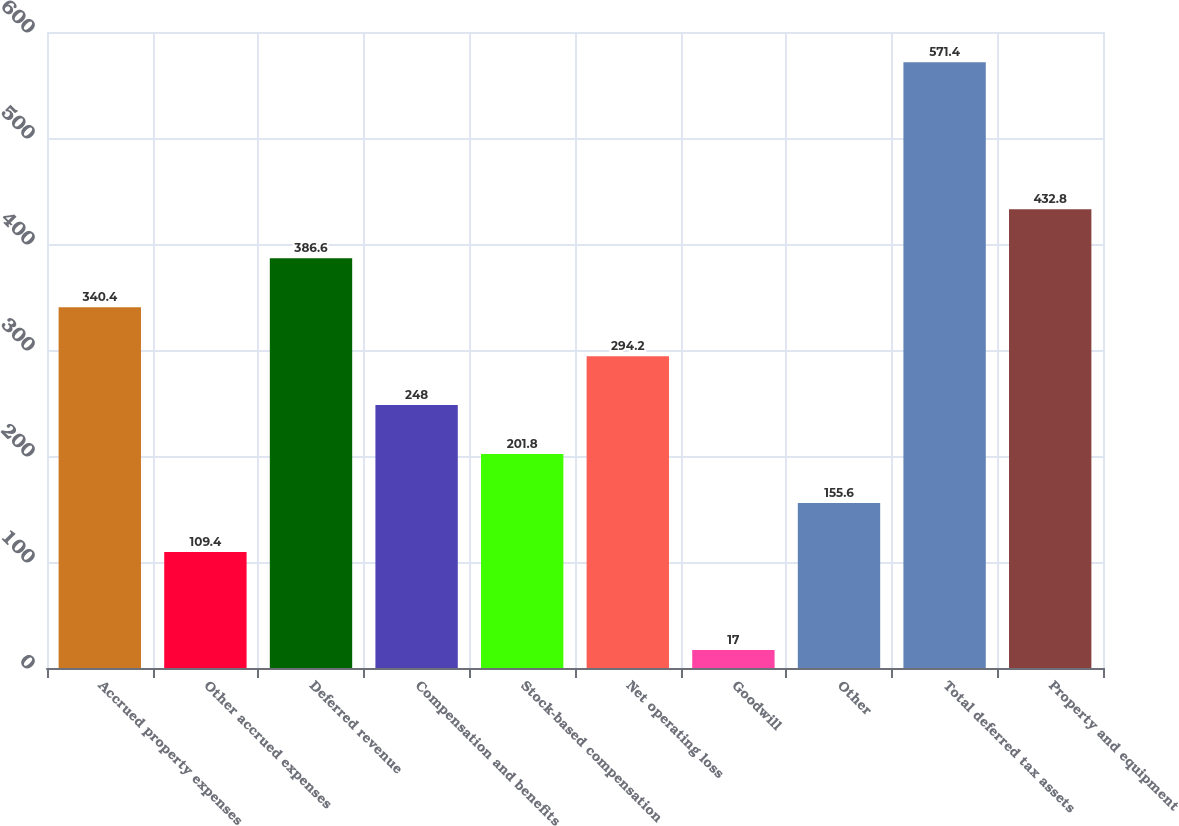<chart> <loc_0><loc_0><loc_500><loc_500><bar_chart><fcel>Accrued property expenses<fcel>Other accrued expenses<fcel>Deferred revenue<fcel>Compensation and benefits<fcel>Stock-based compensation<fcel>Net operating loss<fcel>Goodwill<fcel>Other<fcel>Total deferred tax assets<fcel>Property and equipment<nl><fcel>340.4<fcel>109.4<fcel>386.6<fcel>248<fcel>201.8<fcel>294.2<fcel>17<fcel>155.6<fcel>571.4<fcel>432.8<nl></chart> 